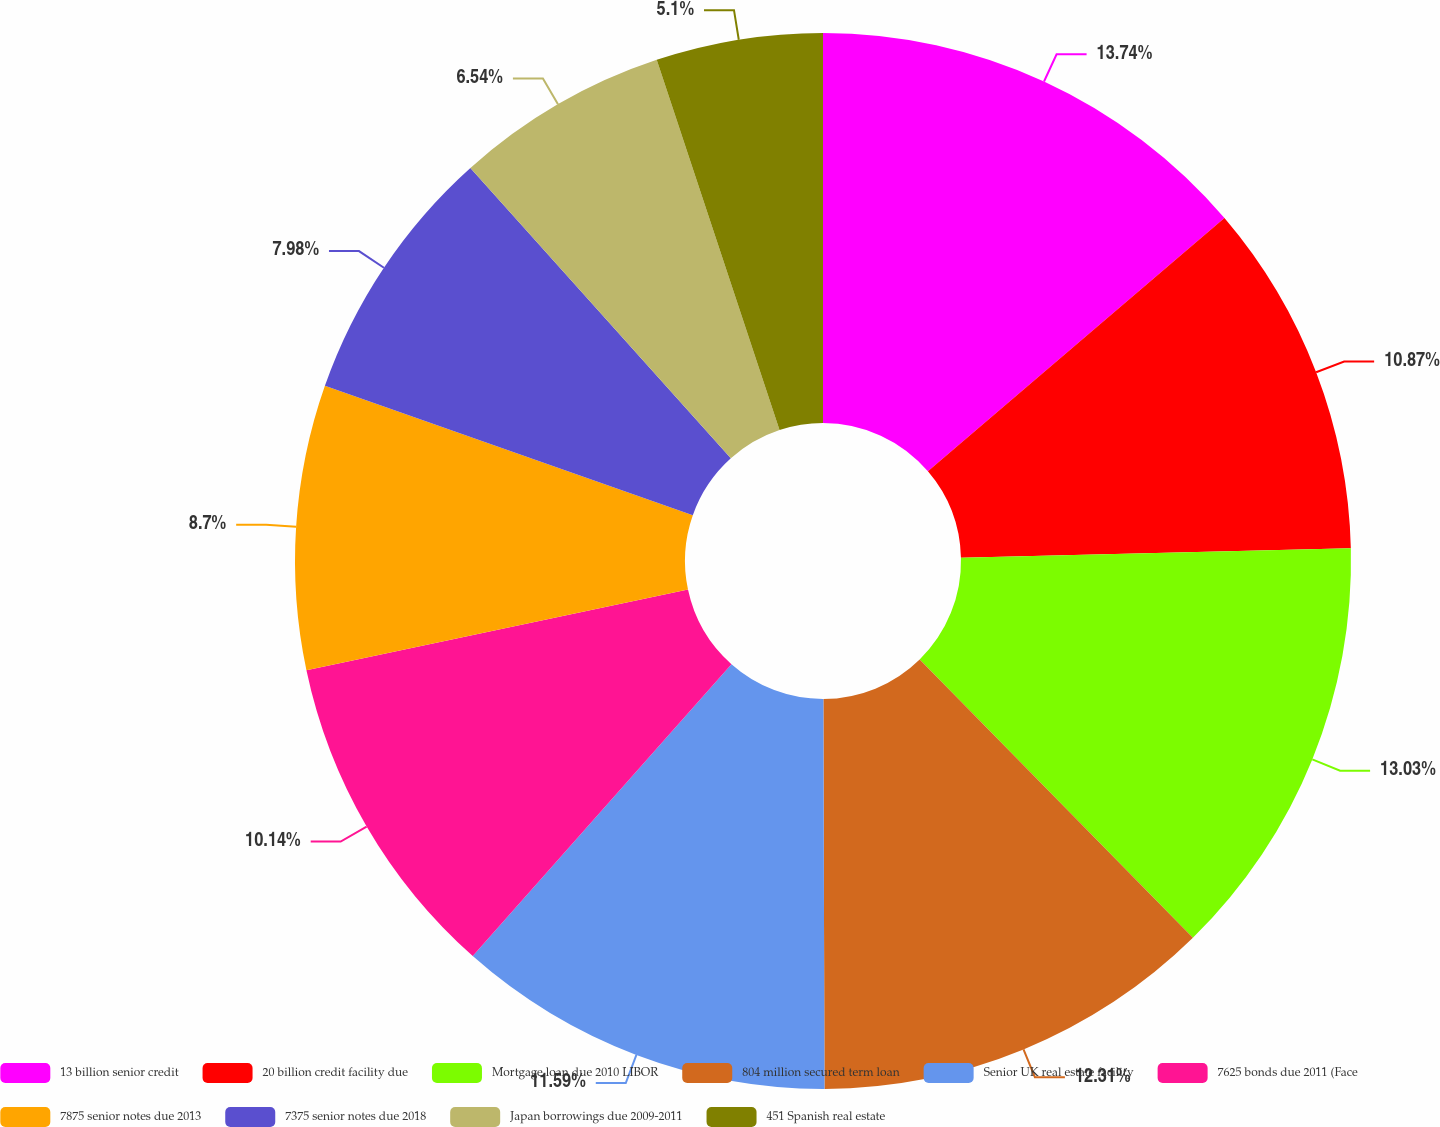Convert chart. <chart><loc_0><loc_0><loc_500><loc_500><pie_chart><fcel>13 billion senior credit<fcel>20 billion credit facility due<fcel>Mortgage loan due 2010 LIBOR<fcel>804 million secured term loan<fcel>Senior UK real estate facility<fcel>7625 bonds due 2011 (Face<fcel>7875 senior notes due 2013<fcel>7375 senior notes due 2018<fcel>Japan borrowings due 2009-2011<fcel>451 Spanish real estate<nl><fcel>13.75%<fcel>10.87%<fcel>13.03%<fcel>12.31%<fcel>11.59%<fcel>10.14%<fcel>8.7%<fcel>7.98%<fcel>6.54%<fcel>5.1%<nl></chart> 